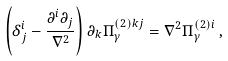<formula> <loc_0><loc_0><loc_500><loc_500>\left ( \delta ^ { i } _ { j } - \frac { \partial ^ { i } \partial _ { j } } { \nabla ^ { 2 } } \right ) \partial _ { k } \Pi ^ { ( 2 ) k j } _ { \gamma } = \nabla ^ { 2 } \Pi ^ { ( 2 ) i } _ { \gamma } \, ,</formula> 